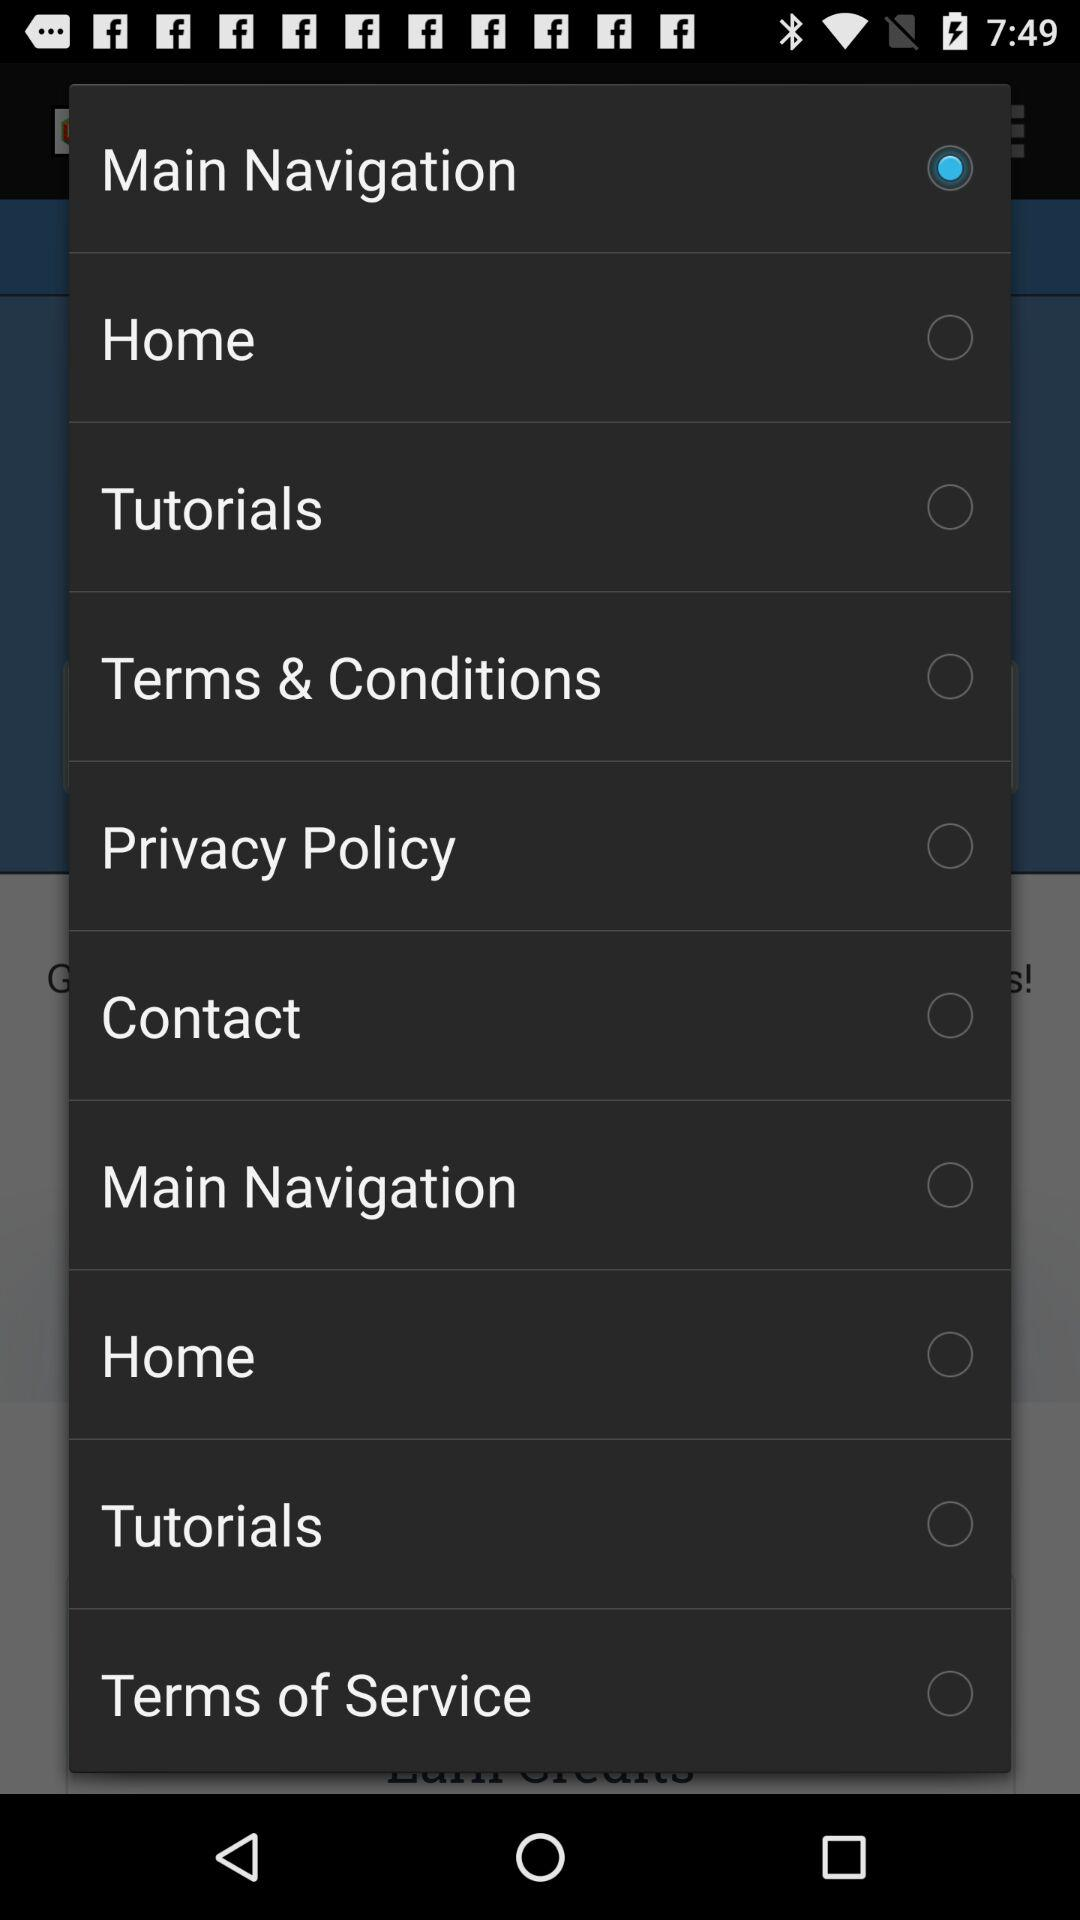What option was selected? The selected option was "Main Navigation". 